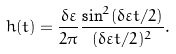Convert formula to latex. <formula><loc_0><loc_0><loc_500><loc_500>h ( t ) = \frac { \delta \varepsilon } { 2 \pi } \frac { \sin ^ { 2 } ( \delta \varepsilon t / 2 ) } { ( \delta \varepsilon t / 2 ) ^ { 2 } } .</formula> 